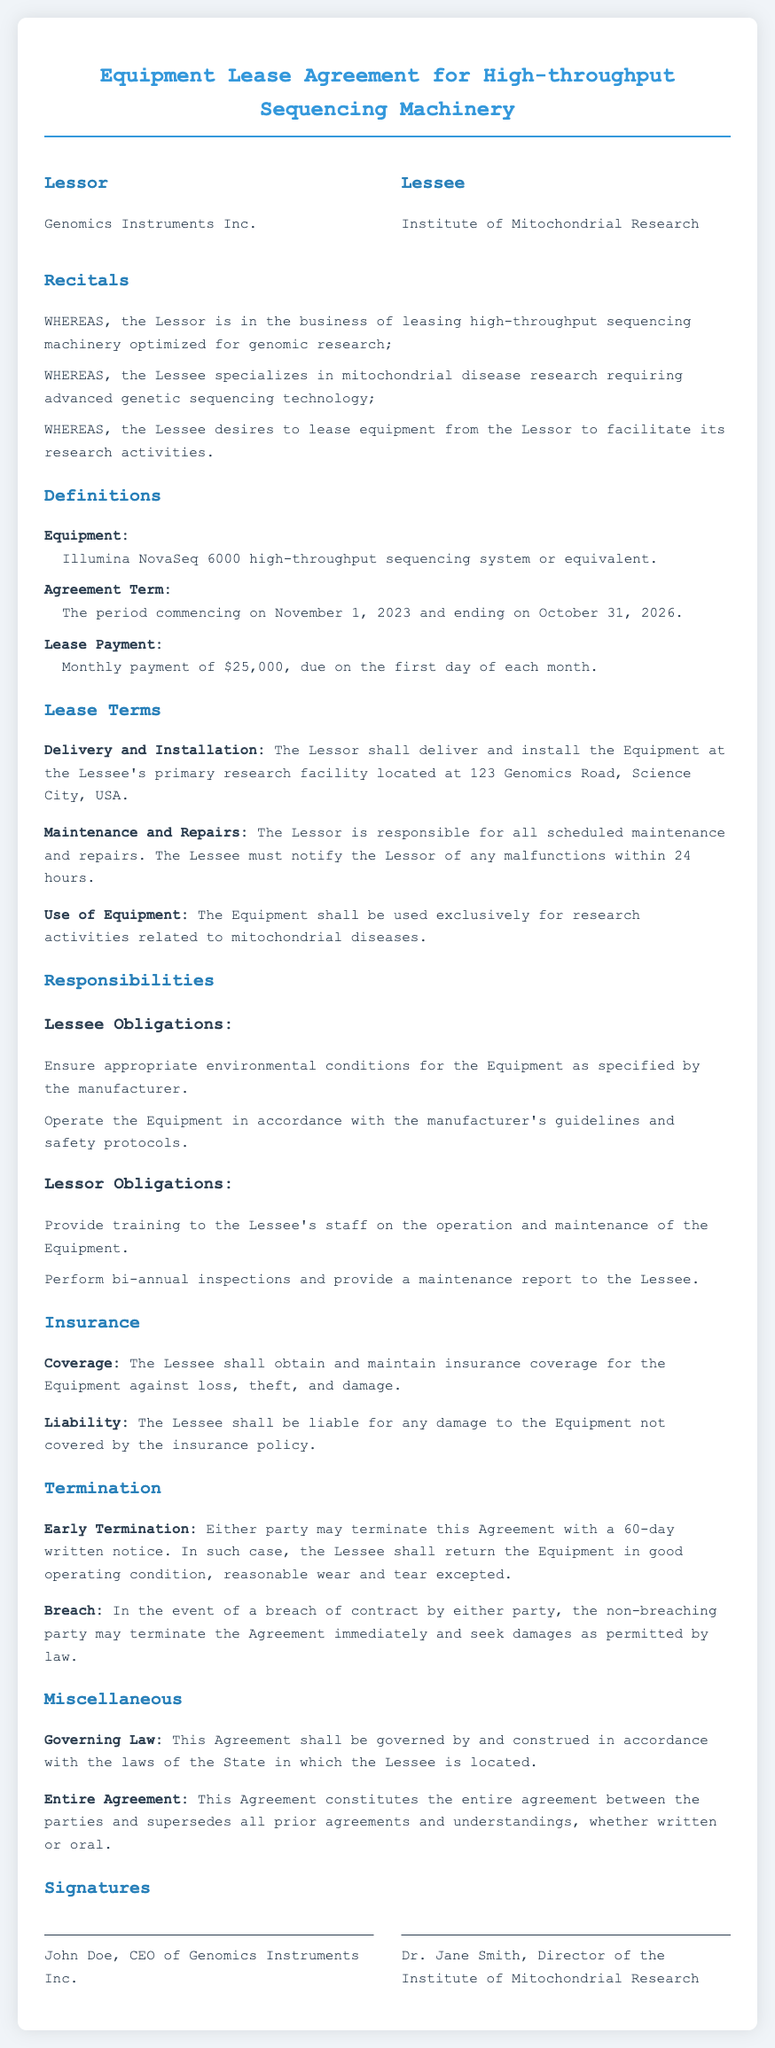What is the name of the Lessor? The name of the Lessor is provided in the "Parties" section of the document.
Answer: Genomics Instruments Inc What is the Equipment being leased? The document specifies the Equipment in the "Definitions" section.
Answer: Illumina NovaSeq 6000 high-throughput sequencing system or equivalent What is the monthly Lease Payment? The Lease Payment is stated in the "Definitions" section as a specific amount due monthly.
Answer: $25,000 What is the Agreement Term duration? The duration of the Agreement Term can be found in the "Definitions" section.
Answer: November 1, 2023, and ending on October 31, 2026 Who is responsible for maintenance and repairs? The responsibilities for maintenance and repairs are outlined in the "Maintenance and Repairs" clause.
Answer: The Lessor What must the Lessee do if there is a malfunction? The process for notifying malfunctions is described in the "Maintenance and Repairs" section.
Answer: Notify the Lessor within 24 hours How long is the notice period for early termination? The notice period for early termination is detailed in the "Termination" section of the document.
Answer: 60 days What does the Lessee need to maintain for the Equipment? The Lessee's obligations regarding the environment for the Equipment are provided under "Lessee Obligations".
Answer: Appropriate environmental conditions What will govern this Agreement? The governing laws applicable to the Agreement are specified in the "Miscellaneous" section.
Answer: The laws of the State in which the Lessee is located 